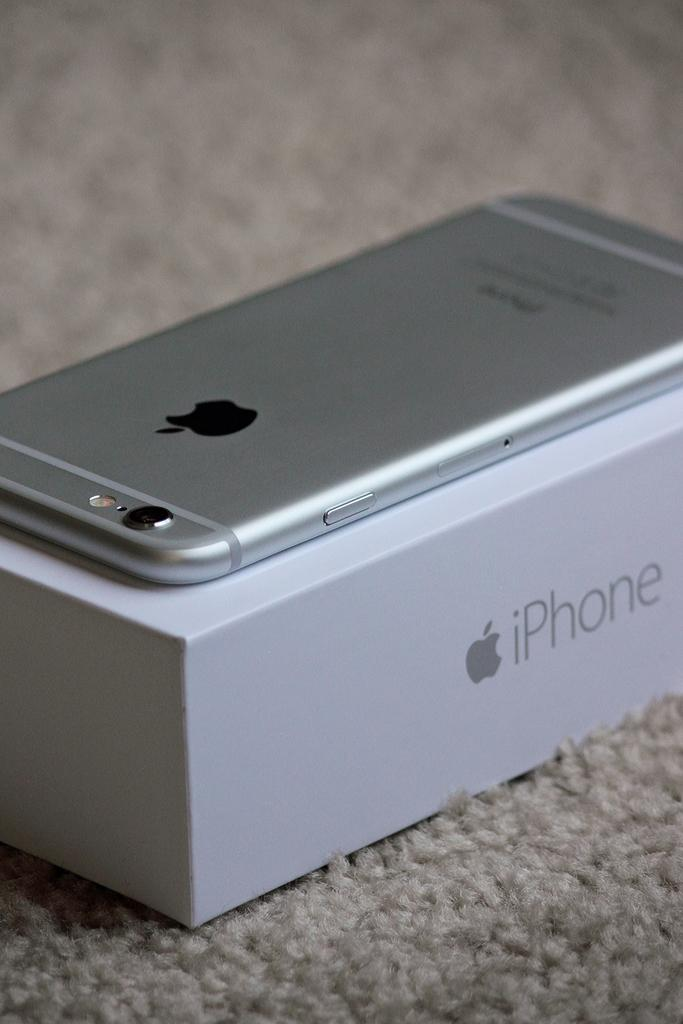<image>
Present a compact description of the photo's key features. An iphone sits on top of an iphone box. 